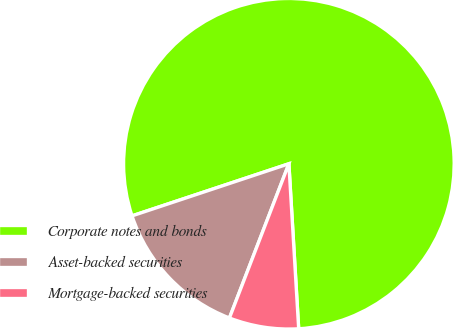Convert chart to OTSL. <chart><loc_0><loc_0><loc_500><loc_500><pie_chart><fcel>Corporate notes and bonds<fcel>Asset-backed securities<fcel>Mortgage-backed securities<nl><fcel>79.16%<fcel>14.04%<fcel>6.8%<nl></chart> 